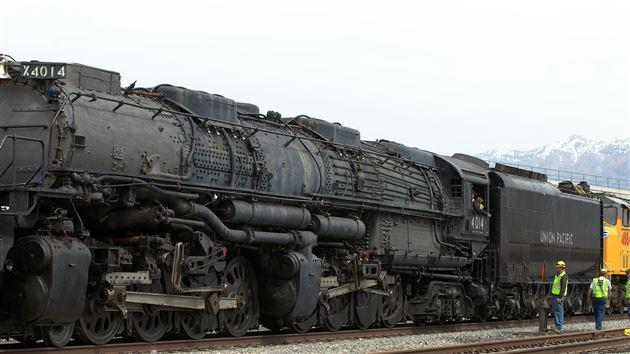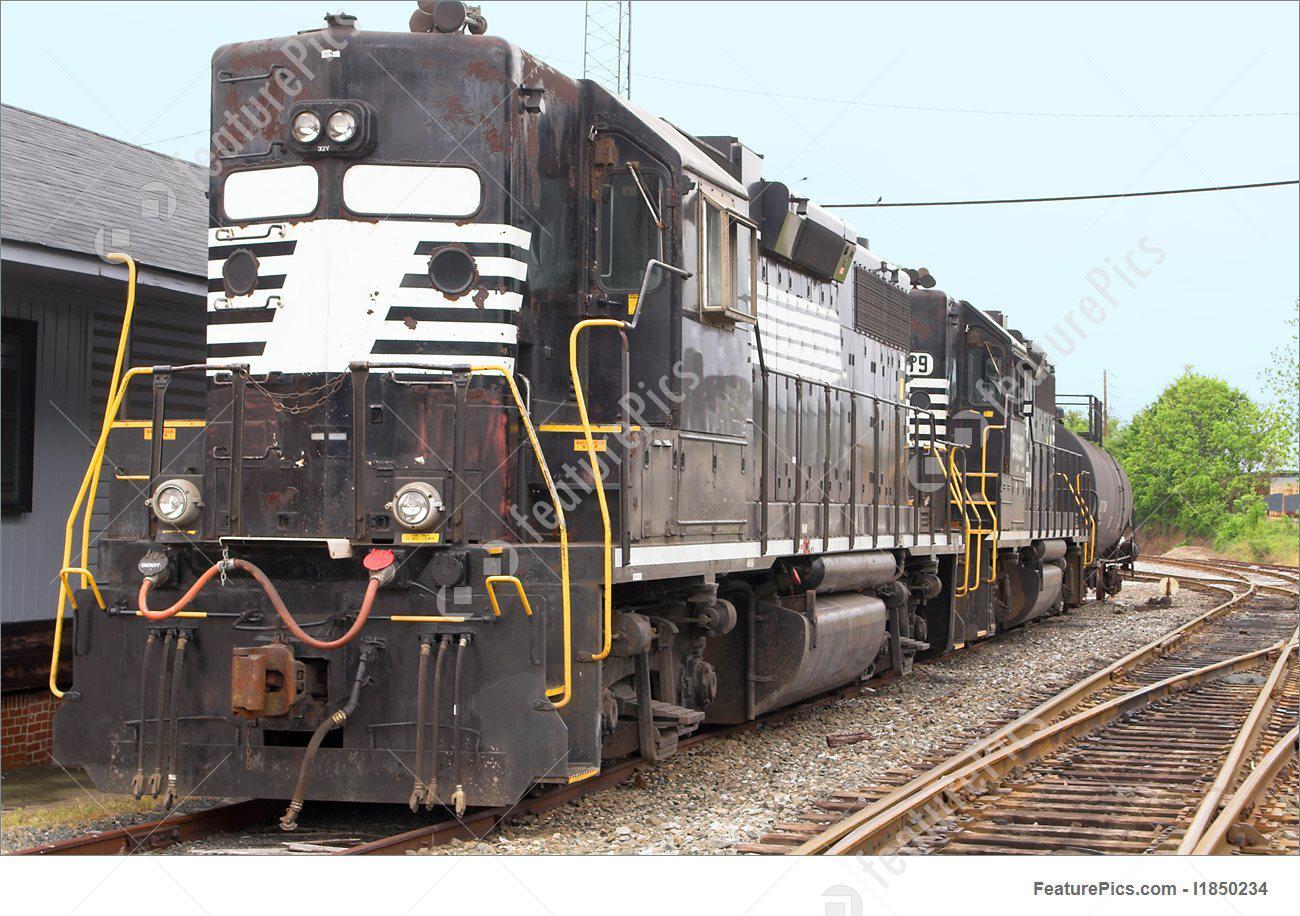The first image is the image on the left, the second image is the image on the right. For the images shown, is this caption "The image on the right contains a vehicle with black and white stripes." true? Answer yes or no. Yes. 